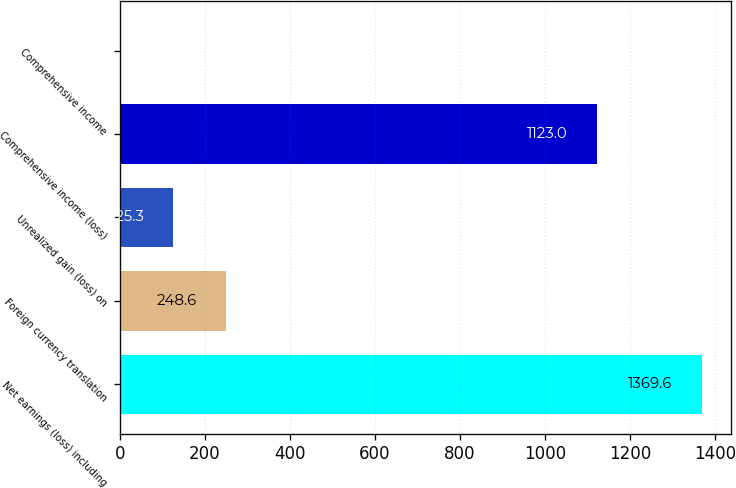<chart> <loc_0><loc_0><loc_500><loc_500><bar_chart><fcel>Net earnings (loss) including<fcel>Foreign currency translation<fcel>Unrealized gain (loss) on<fcel>Comprehensive income (loss)<fcel>Comprehensive income<nl><fcel>1369.6<fcel>248.6<fcel>125.3<fcel>1123<fcel>2<nl></chart> 